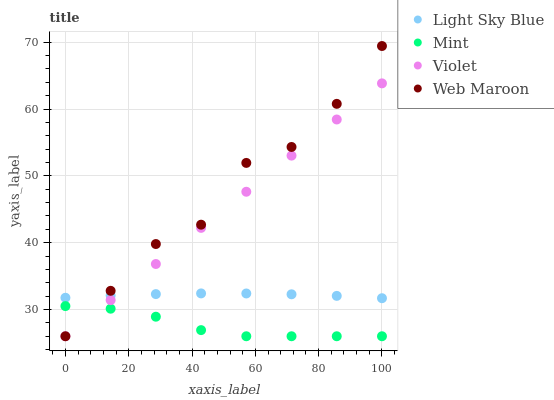Does Mint have the minimum area under the curve?
Answer yes or no. Yes. Does Web Maroon have the maximum area under the curve?
Answer yes or no. Yes. Does Light Sky Blue have the minimum area under the curve?
Answer yes or no. No. Does Light Sky Blue have the maximum area under the curve?
Answer yes or no. No. Is Violet the smoothest?
Answer yes or no. Yes. Is Web Maroon the roughest?
Answer yes or no. Yes. Is Light Sky Blue the smoothest?
Answer yes or no. No. Is Light Sky Blue the roughest?
Answer yes or no. No. Does Web Maroon have the lowest value?
Answer yes or no. Yes. Does Light Sky Blue have the lowest value?
Answer yes or no. No. Does Web Maroon have the highest value?
Answer yes or no. Yes. Does Light Sky Blue have the highest value?
Answer yes or no. No. Is Mint less than Light Sky Blue?
Answer yes or no. Yes. Is Light Sky Blue greater than Mint?
Answer yes or no. Yes. Does Violet intersect Light Sky Blue?
Answer yes or no. Yes. Is Violet less than Light Sky Blue?
Answer yes or no. No. Is Violet greater than Light Sky Blue?
Answer yes or no. No. Does Mint intersect Light Sky Blue?
Answer yes or no. No. 